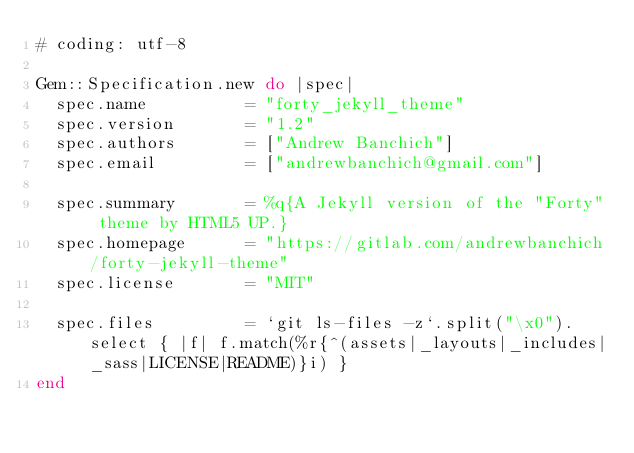Convert code to text. <code><loc_0><loc_0><loc_500><loc_500><_Ruby_># coding: utf-8

Gem::Specification.new do |spec|
  spec.name          = "forty_jekyll_theme"
  spec.version       = "1.2"
  spec.authors       = ["Andrew Banchich"]
  spec.email         = ["andrewbanchich@gmail.com"]

  spec.summary       = %q{A Jekyll version of the "Forty" theme by HTML5 UP.}
  spec.homepage      = "https://gitlab.com/andrewbanchich/forty-jekyll-theme"
  spec.license       = "MIT"

  spec.files         = `git ls-files -z`.split("\x0").select { |f| f.match(%r{^(assets|_layouts|_includes|_sass|LICENSE|README)}i) }
end
</code> 